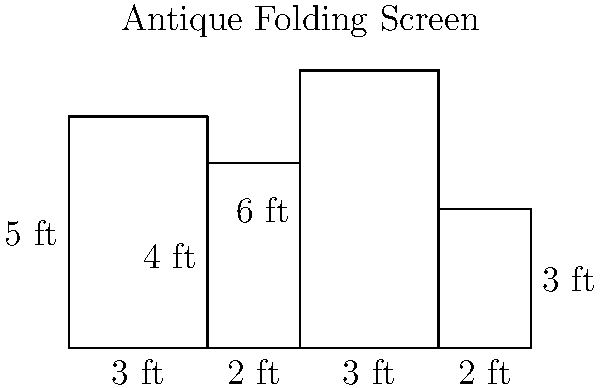You've discovered an antique folding screen at a flea market with four rectangular panels of varying sizes. The dimensions of each panel are shown in the diagram above. What is the total surface area of the folding screen in square feet? To find the total surface area of the folding screen, we need to calculate the area of each panel and then sum them up. Let's go through this step-by-step:

1. Panel 1: 
   Width = 3 ft, Height = 5 ft
   Area = $3 \times 5 = 15$ sq ft

2. Panel 2:
   Width = 2 ft, Height = 4 ft
   Area = $2 \times 4 = 8$ sq ft

3. Panel 3:
   Width = 3 ft, Height = 6 ft
   Area = $3 \times 6 = 18$ sq ft

4. Panel 4:
   Width = 2 ft, Height = 3 ft
   Area = $2 \times 3 = 6$ sq ft

Now, we sum up the areas of all panels:

Total Area = Panel 1 + Panel 2 + Panel 3 + Panel 4
           = $15 + 8 + 18 + 6$
           = $47$ sq ft

Therefore, the total surface area of the antique folding screen is 47 square feet.
Answer: 47 sq ft 